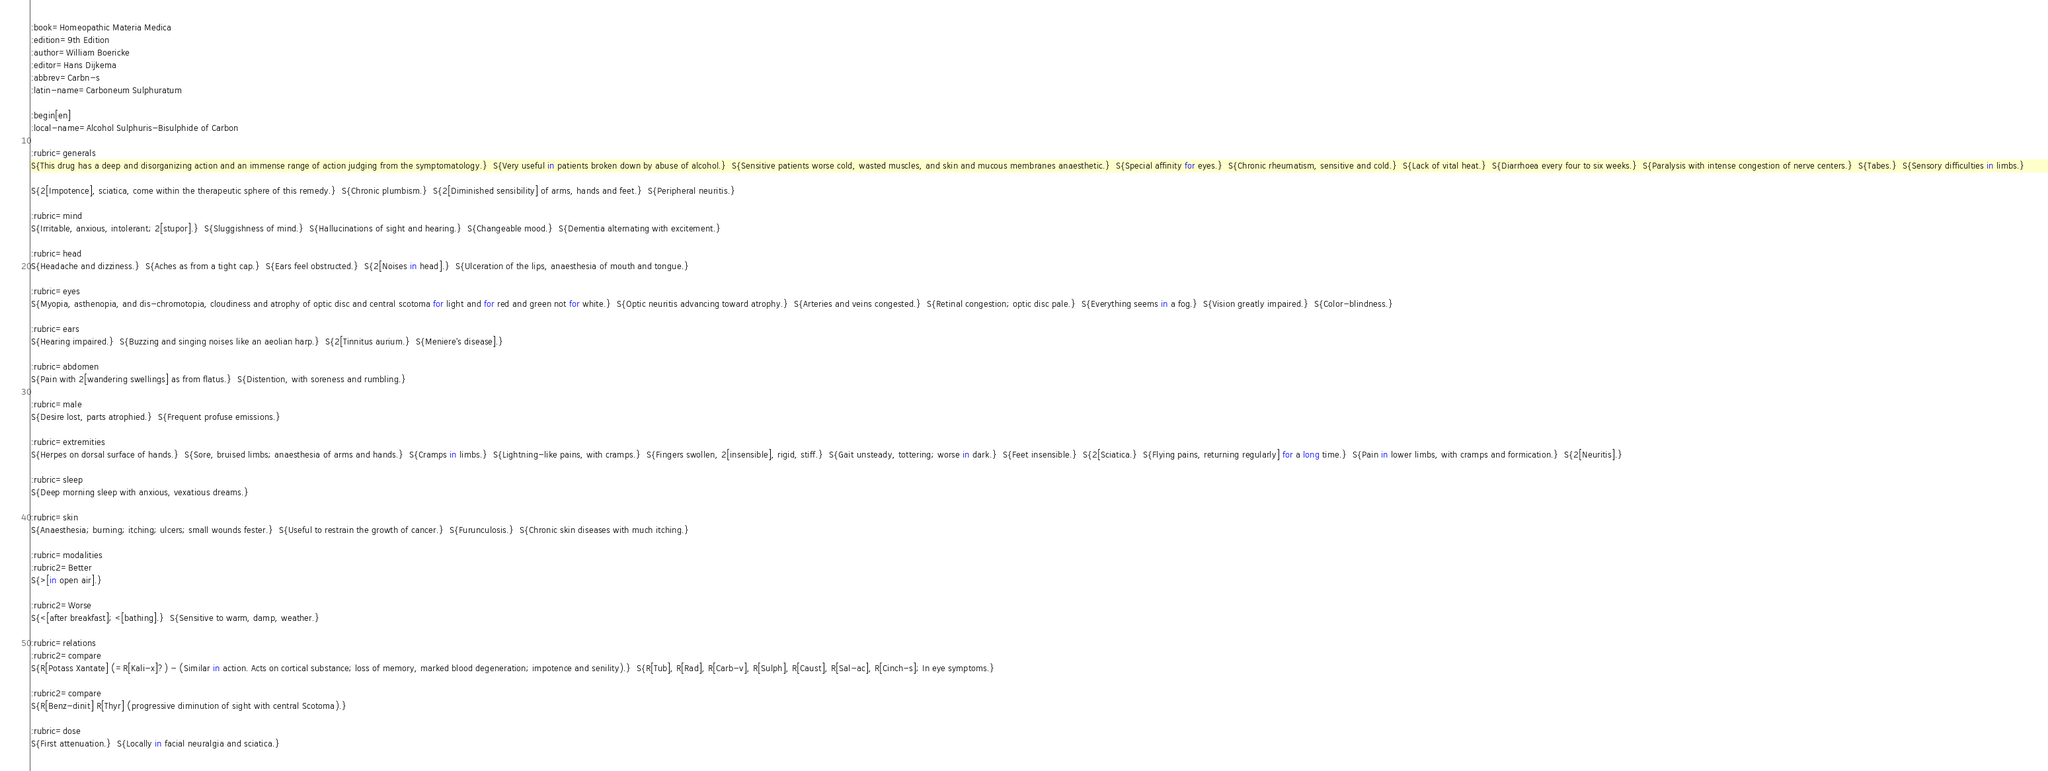Convert code to text. <code><loc_0><loc_0><loc_500><loc_500><_ObjectiveC_>:book=Homeopathic Materia Medica
:edition=9th Edition
:author=William Boericke
:editor=Hans Dijkema
:abbrev=Carbn-s
:latin-name=Carboneum Sulphuratum

:begin[en]
:local-name=Alcohol Sulphuris-Bisulphide of Carbon

:rubric=generals
S{This drug has a deep and disorganizing action and an immense range of action judging from the symptomatology.}  S{Very useful in patients broken down by abuse of alcohol.}  S{Sensitive patients worse cold, wasted muscles, and skin and mucous membranes anaesthetic.}  S{Special affinity for eyes.}  S{Chronic rheumatism, sensitive and cold.}  S{Lack of vital heat.}  S{Diarrhoea every four to six weeks.}  S{Paralysis with intense congestion of nerve centers.}  S{Tabes.}  S{Sensory difficulties in limbs.} 

S{2[Impotence], sciatica, come within the therapeutic sphere of this remedy.}  S{Chronic plumbism.}  S{2[Diminished sensibility] of arms, hands and feet.}  S{Peripheral neuritis.} 

:rubric=mind
S{Irritable, anxious, intolerant; 2[stupor].}  S{Sluggishness of mind.}  S{Hallucinations of sight and hearing.}  S{Changeable mood.}  S{Dementia alternating with excitement.} 

:rubric=head
S{Headache and dizziness.}  S{Aches as from a tight cap.}  S{Ears feel obstructed.}  S{2[Noises in head].}  S{Ulceration of the lips, anaesthesia of mouth and tongue.} 

:rubric=eyes
S{Myopia, asthenopia, and dis-chromotopia, cloudiness and atrophy of optic disc and central scotoma for light and for red and green not for white.}  S{Optic neuritis advancing toward atrophy.}  S{Arteries and veins congested.}  S{Retinal congestion; optic disc pale.}  S{Everything seems in a fog.}  S{Vision greatly impaired.}  S{Color-blindness.} 

:rubric=ears
S{Hearing impaired.}  S{Buzzing and singing noises like an aeolian harp.}  S{2[Tinnitus aurium.}  S{Meniere's disease].} 

:rubric=abdomen
S{Pain with 2[wandering swellings] as from flatus.}  S{Distention, with soreness and rumbling.} 

:rubric=male
S{Desire lost, parts atrophied.}  S{Frequent profuse emissions.} 

:rubric=extremities
S{Herpes on dorsal surface of hands.}  S{Sore, bruised limbs; anaesthesia of arms and hands.}  S{Cramps in limbs.}  S{Lightning-like pains, with cramps.}  S{Fingers swollen, 2[insensible], rigid, stiff.}  S{Gait unsteady, tottering; worse in dark.}  S{Feet insensible.}  S{2[Sciatica.}  S{Flying pains, returning regularly] for a long time.}  S{Pain in lower limbs, with cramps and formication.}  S{2[Neuritis].} 

:rubric=sleep
S{Deep morning sleep with anxious, vexatious dreams.} 

:rubric=skin
S{Anaesthesia; burning; itching; ulcers; small wounds fester.}  S{Useful to restrain the growth of cancer.}  S{Furunculosis.}  S{Chronic skin diseases with much itching.} 

:rubric=modalities
:rubric2=Better
S{>[in open air].}  

:rubric2=Worse
S{<[after breakfast]; <[bathing].}  S{Sensitive to warm, damp, weather.} 

:rubric=relations
:rubric2=compare
S{R[Potass Xantate] (=R[Kali-x]?) - (Similar in action. Acts on cortical substance; loss of memory, marked blood degeneration; impotence and senility).}  S{R[Tub], R[Rad], R[Carb-v], R[Sulph], R[Caust], R[Sal-ac], R[Cinch-s]; In eye symptoms.}

:rubric2=compare
S{R[Benz-dinit] R[Thyr] (progressive diminution of sight with central Scotoma).} 

:rubric=dose
S{First attenuation.}  S{Locally in facial neuralgia and sciatica.}</code> 